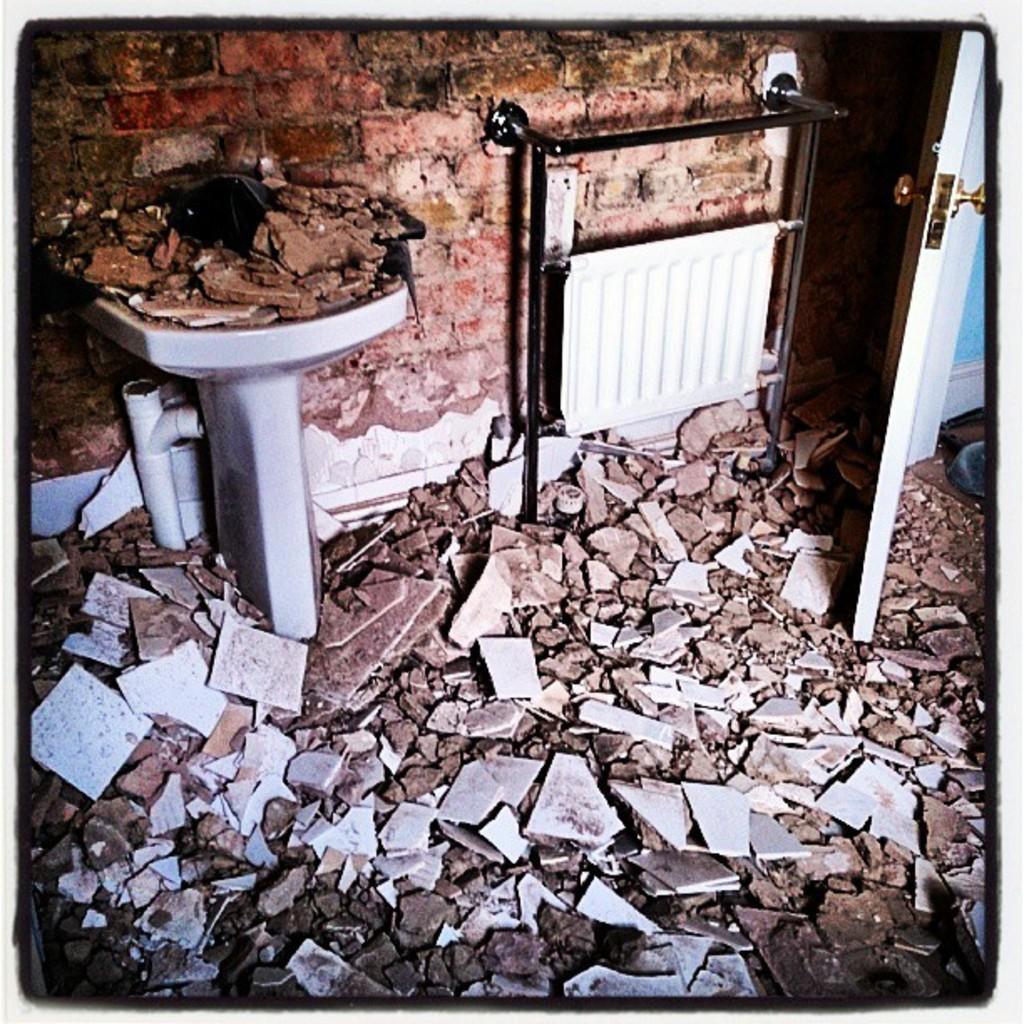Describe this image in one or two sentences. In the picture I can see a wash basin which has few objects placed on it in the left corner and there are few broken tiles below it and there is a door in the right corner and there is an object behind it. 